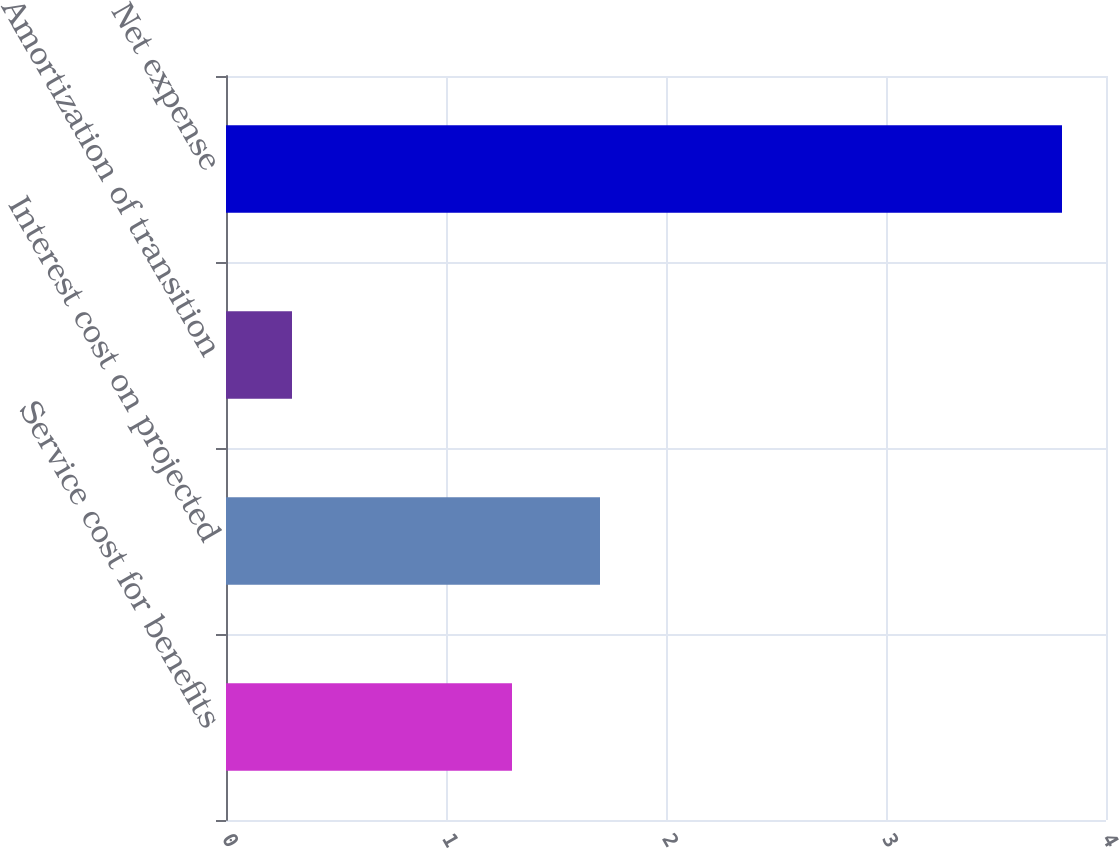<chart> <loc_0><loc_0><loc_500><loc_500><bar_chart><fcel>Service cost for benefits<fcel>Interest cost on projected<fcel>Amortization of transition<fcel>Net expense<nl><fcel>1.3<fcel>1.7<fcel>0.3<fcel>3.8<nl></chart> 